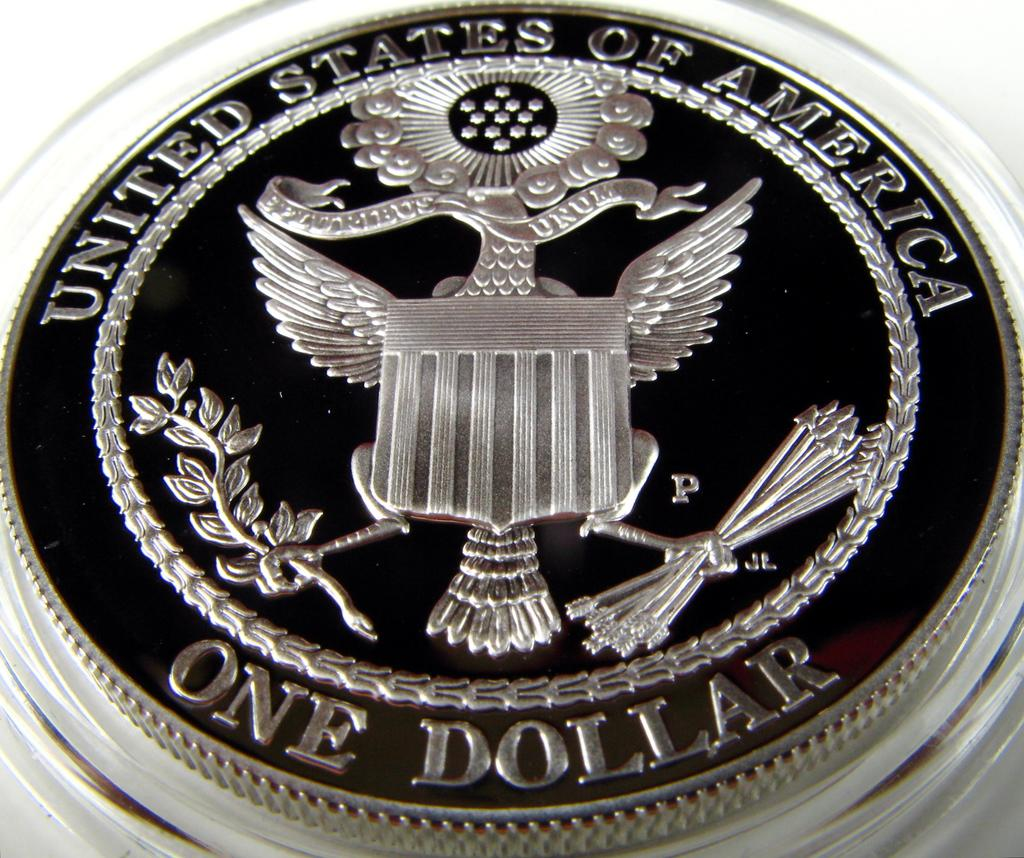<image>
Share a concise interpretation of the image provided. A black and silver United States of America One Dollar coin sits inside of a clear display case 